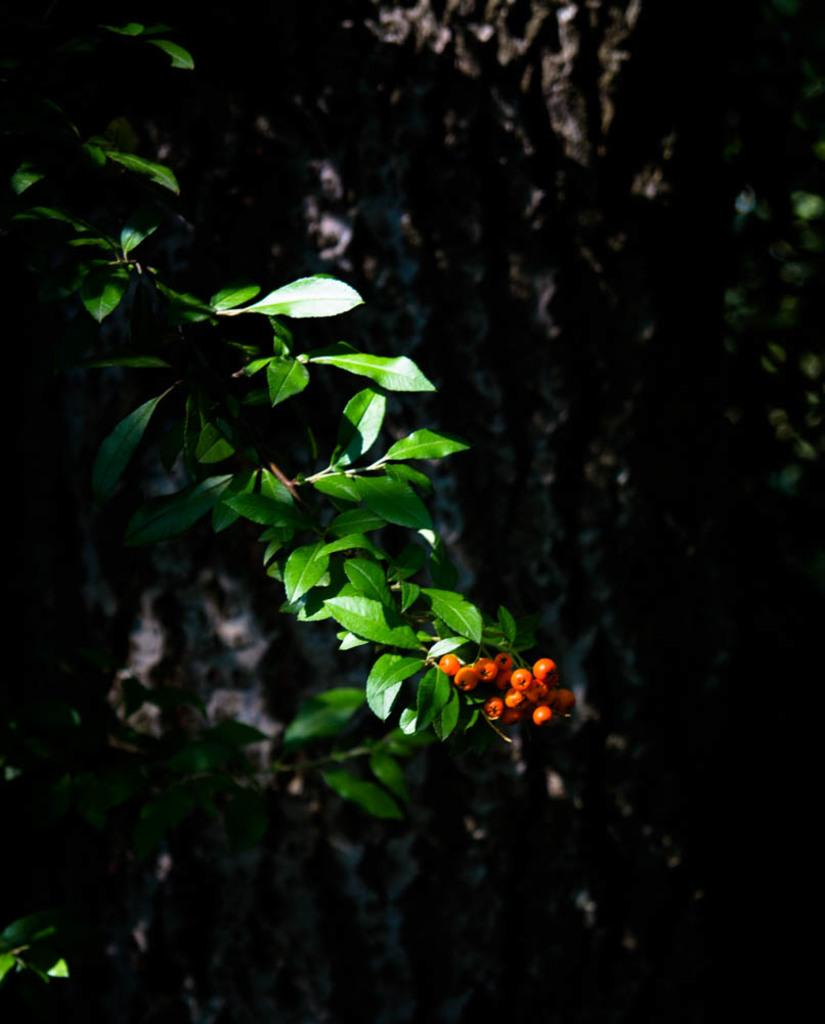What type of fruit can be seen in the image? There are berries in the image. What else is present in the image besides the berries? There are leaves in the image. Can you describe the background of the image? The background of the image is dark. What type of gate can be seen in the image? There is no gate present in the image; it only features berries and leaves. What type of shop is visible in the image? There is no shop present in the image; it only features berries and leaves. 